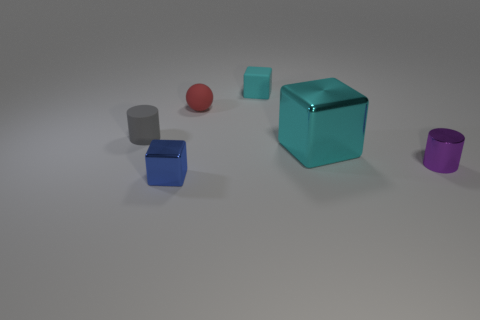How many small cyan rubber objects have the same shape as the big metal thing?
Provide a succinct answer. 1. What material is the small cube behind the small block on the left side of the cyan rubber block made of?
Ensure brevity in your answer.  Rubber. What is the shape of the tiny matte object that is the same color as the large thing?
Your answer should be compact. Cube. Are there any large cyan objects that have the same material as the red object?
Make the answer very short. No. What shape is the tiny cyan matte thing?
Your response must be concise. Cube. What number of yellow cylinders are there?
Make the answer very short. 0. What color is the small cube in front of the tiny block that is on the right side of the small metal cube?
Provide a short and direct response. Blue. There is a metallic block that is the same size as the red rubber object; what is its color?
Your answer should be very brief. Blue. Are there any tiny rubber things of the same color as the large shiny object?
Your answer should be compact. Yes. Are there any small blue objects?
Provide a succinct answer. Yes. 